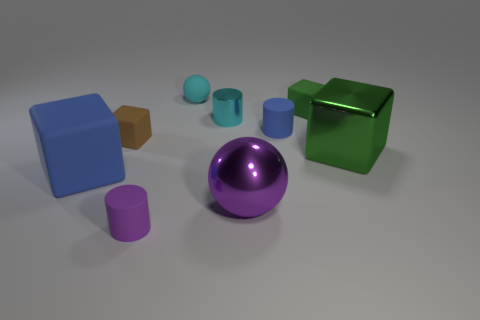There is a brown rubber thing that is on the left side of the big object that is behind the big cube to the left of the big purple thing; what is its size?
Your response must be concise. Small. What size is the blue cube that is made of the same material as the small brown cube?
Give a very brief answer. Large. Does the cyan matte sphere have the same size as the green block that is to the left of the big metallic block?
Offer a very short reply. Yes. What shape is the blue object that is to the right of the cyan metal thing?
Your answer should be very brief. Cylinder. Is there a large blue cube in front of the matte block to the right of the small cyan object that is in front of the small green cube?
Ensure brevity in your answer.  Yes. There is a blue thing that is the same shape as the tiny cyan metallic object; what is it made of?
Provide a succinct answer. Rubber. Is there anything else that has the same material as the large purple thing?
Provide a short and direct response. Yes. How many spheres are either brown rubber objects or small cyan metal objects?
Keep it short and to the point. 0. There is a green block that is behind the large green cube; is it the same size as the shiny object in front of the big blue cube?
Offer a terse response. No. There is a small thing left of the purple object on the left side of the cyan cylinder; what is it made of?
Make the answer very short. Rubber. 